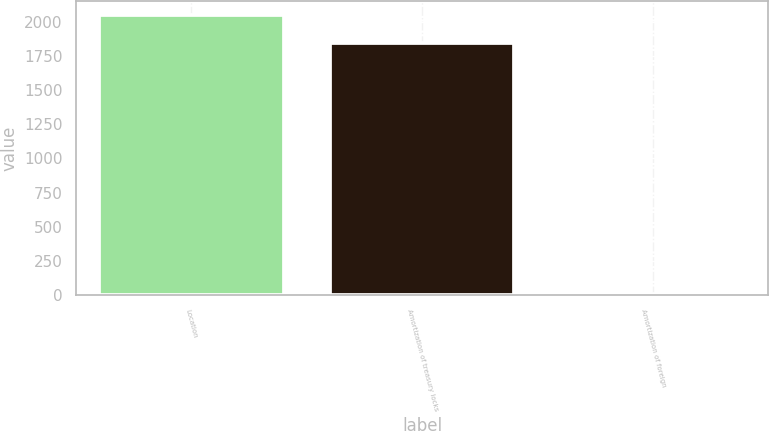Convert chart. <chart><loc_0><loc_0><loc_500><loc_500><bar_chart><fcel>Location<fcel>Amortization of treasury locks<fcel>Amortization of foreign<nl><fcel>2046.4<fcel>1846<fcel>7<nl></chart> 